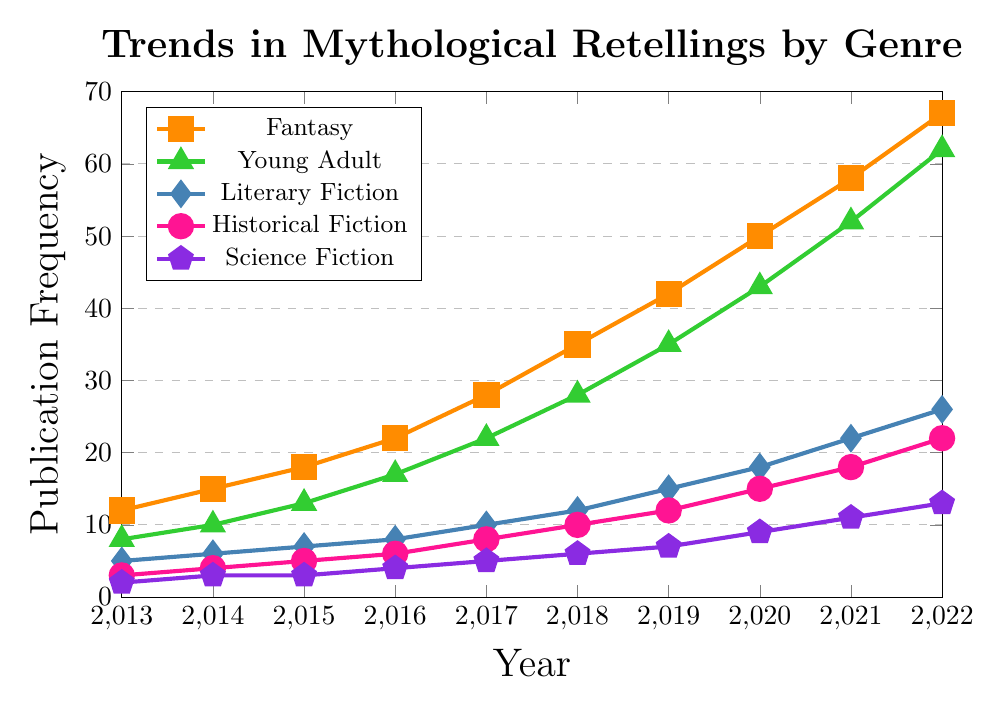What's the trend in publication frequency for Fantasy from 2013 to 2022? First, identify the data points for Fantasy from 2013 to 2022 and observe the changes. The frequency increases consistently: 12 (2013), 15 (2014), 18 (2015), 22 (2016), 28 (2017), 35 (2018), 42 (2019), 50 (2020), 58 (2021), 67 (2022).
Answer: Increasing Which genre had the lowest publication frequency in 2013? Look at the data points for each genre in 2013: Fantasy (12), Young Adult (8), Literary Fiction (5), Historical Fiction (3), Science Fiction (2). The lowest value is 2 for Science Fiction.
Answer: Science Fiction How many more publications were there in Historical Fiction in 2022 compared to 2013? Find the publication frequencies for Historical Fiction in 2022 (22) and 2013 (3). Calculate the difference: 22 - 3 = 19.
Answer: 19 Between which consecutive years did Young Adult see the largest increase in publications? Calculate the year-over-year differences for Young Adult: (10-8)=2, (13-10)=3, (17-13)=4, (22-17)=5, (28-22)=6, (35-28)=7, (43-35)=8, (52-43)=9, (62-52)=10. The largest increase is from 2021 to 2022 with an increase of 10.
Answer: 2021 to 2022 Which genre saw the steadiest increase in publication frequency over the decade? Examine how smooth and consistent the line increases for each genre. Fantasy, Young Adult, Literary Fiction, Historical Fiction, and Science Fiction all show steady increases, but the increments for Fantasy are the most consistent without dramatic jumps or drops.
Answer: Fantasy What is the difference in the publication frequency between Fantasy and Science Fiction in 2022? Find the publication frequencies for Fantasy (67) and Science Fiction (13) in 2022. Calculate the difference: 67 - 13 = 54.
Answer: 54 Which genre had the second highest publication frequency in 2020? Look at the publication frequencies for 2020: Fantasy (50), Young Adult (43), Literary Fiction (18), Historical Fiction (15), Science Fiction (9). The second highest frequency is 43 for Young Adult.
Answer: Young Adult What is the average publication frequency for Literary Fiction from 2013 to 2022? Add up the publication frequencies for Literary Fiction from 2013 to 2022: 5 + 6 + 7 + 8 + 10 + 12 + 15 + 18 + 22 + 26 = 129. Divide by 10 (number of years): 129 / 10 = 12.9.
Answer: 12.9 Compare the publication trends of Fantasy and Young Adult from 2017 to 2022. Which genre grew faster? Calculate the differences for Fantasy (67-28) = 39 and Young Adult (62-22) = 40. Both genres had a significant increase, but Young Adult grew faster with an increase of 40 compared to Fantasy's 39.
Answer: Young Adult Which genre shows the least growth in publication frequency over the decade? Compare the initial and final values for each genre: Fantasy (12 to 67), Young Adult (8 to 62), Literary Fiction (5 to 26), Historical Fiction (3 to 22), Science Fiction (2 to 13). The smallest growth is for Science Fiction (2 to 13), an increase of 11.
Answer: Science Fiction 